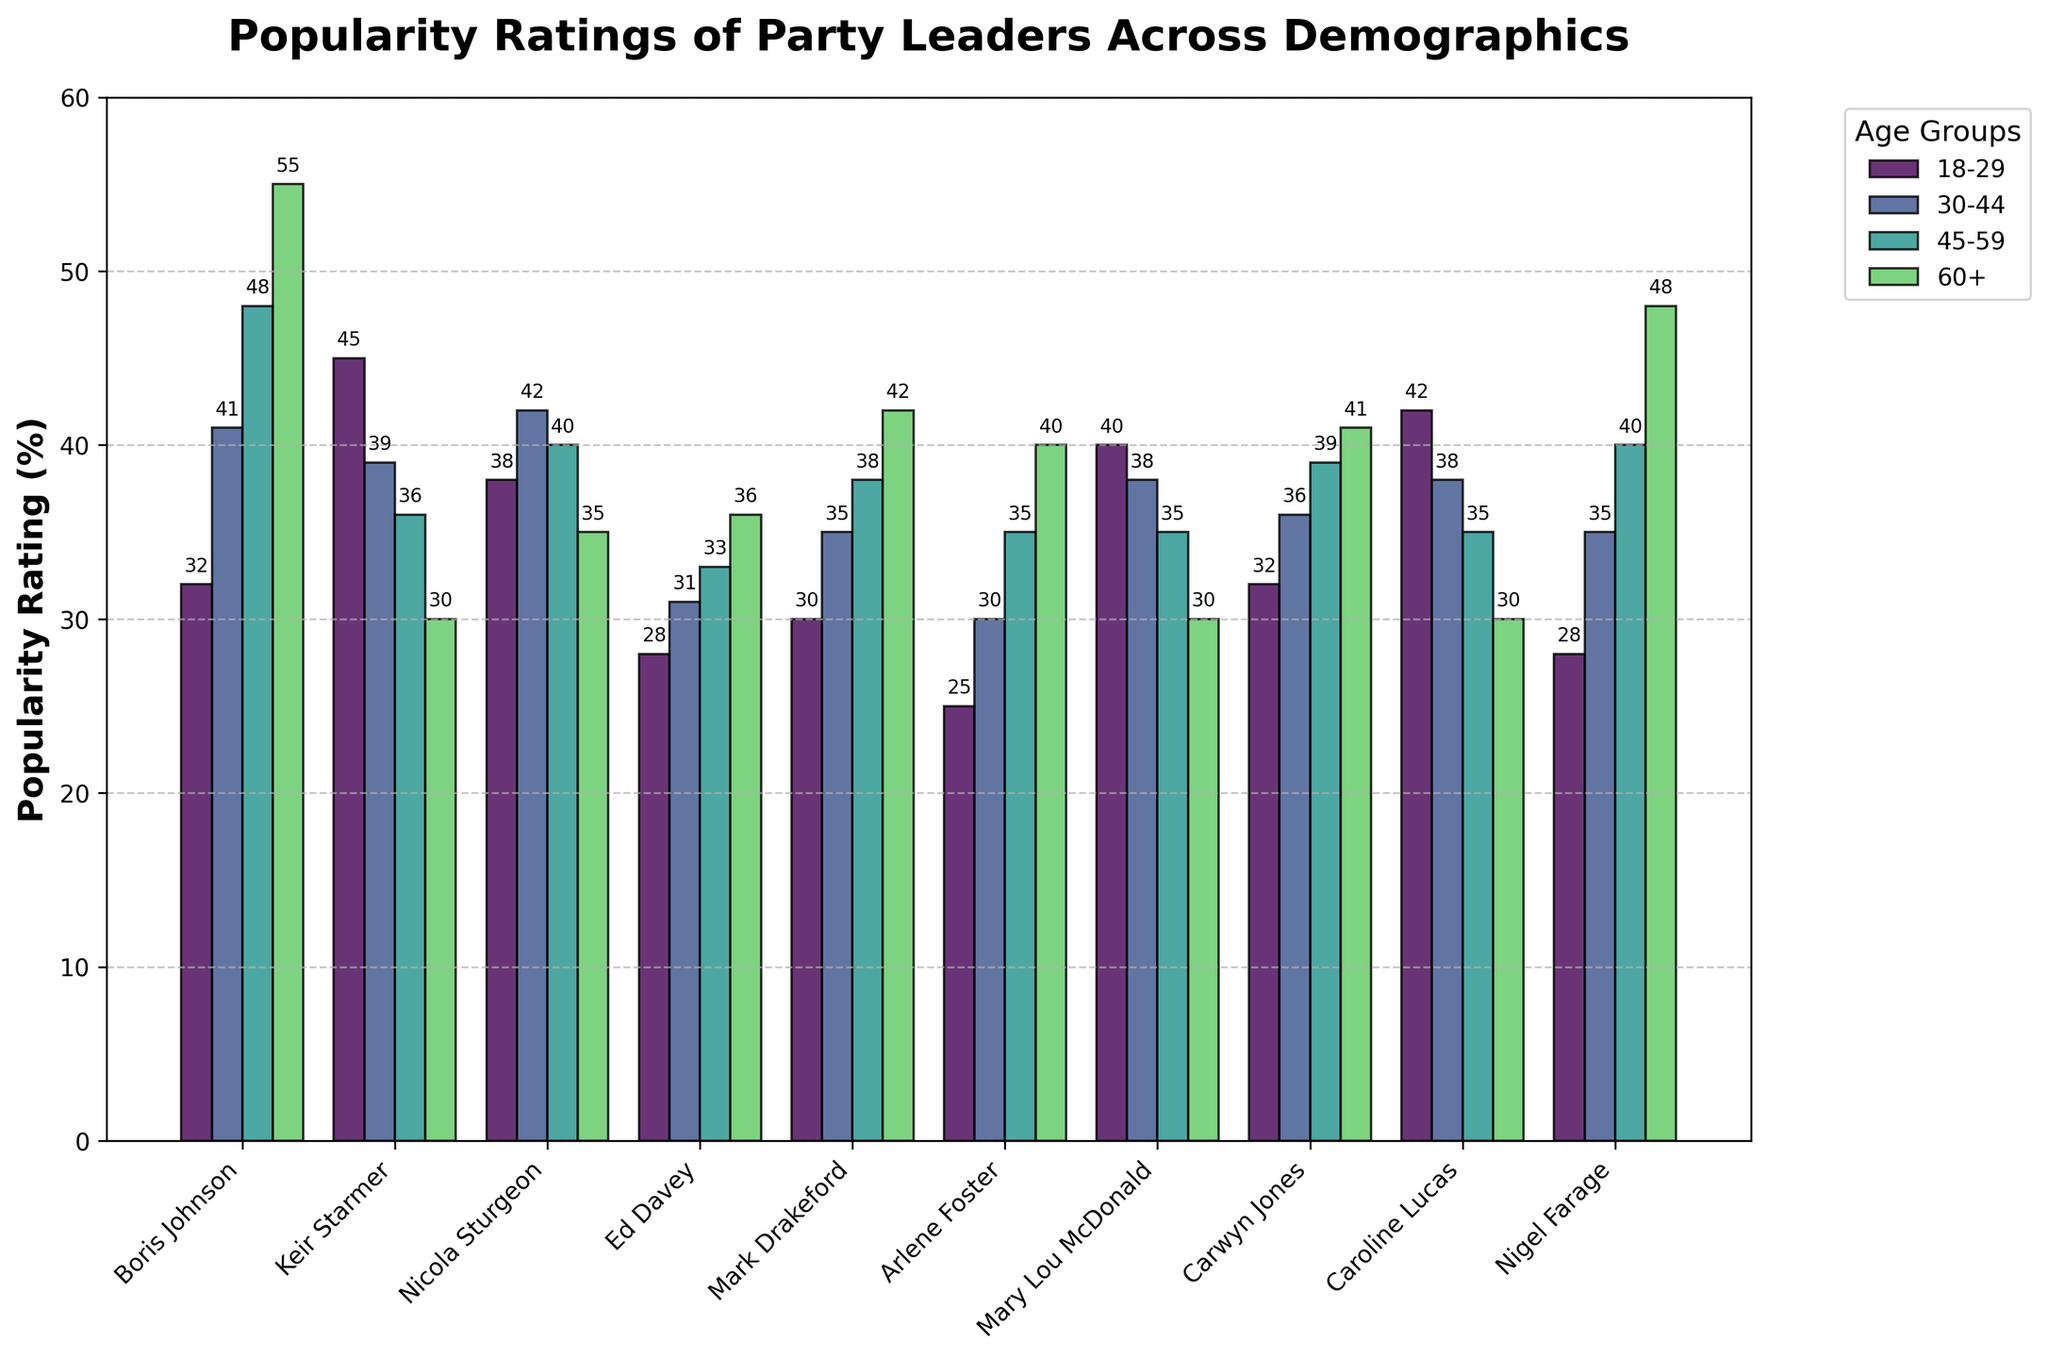What is the popularity rating of Boris Johnson among those aged 60+? Look for the bar corresponding to Boris Johnson and the age group 60+. The top of this bar indicates his popularity rating for this group, which is 55%.
Answer: 55 Who has the highest popularity rating among those aged 18-29? Identify the bars corresponding to the 18-29 age group for all leaders. Caroline Lucas has the highest bar with a rating of 42%.
Answer: Caroline Lucas Compare the popularity ratings of Keir Starmer and Mary Lou McDonald among the 45-59 age group. Who is more popular? Look for the bars corresponding to Keir Starmer and Mary Lou McDonald in the 45-59 age group. Keir Starmer's rating is 36%, while Mary Lou McDonald's rating is 35%. Keir Starmer is more popular.
Answer: Keir Starmer Which leader shows the largest increase in popularity rating from the 18-29 to the 60+ age group and by how much? Calculate the difference in popularity ratings for all leaders between the 18-29 and the 60+ age groups. Boris Johnson shows the largest increase from 32% to 55%, which is an increment of 23%.
Answer: Boris Johnson, 23% Sum the popularity ratings of Caroline Lucas across all age groups. Add the popularity ratings of Caroline Lucas: 42% (18-29) + 38% (30-44) + 35% (45-59) + 30% (60+). Calculate the total sum: 42 + 38 + 35 + 30 = 145%.
Answer: 145 Who has the lowest popularity rating among those aged 30-44? Identify the bars corresponding to the 30-44 age group for all leaders. Arlene Foster has the lowest bar with a rating of 30%.
Answer: Arlene Foster What is the average popularity rating of Ed Davey across all age groups? Calculate the average of Ed Davey's popularity ratings: (28% + 31% + 33% + 36%) / 4. Sum up the values first: 28 + 31 + 33 + 36 = 128. Then, divide by 4: 128 / 4 = 32%.
Answer: 32 Identify the leader whose popularity rating decreases consistently across each older age group. For each leader, check if the rating decreases from one age group to the next older one. Mary Lou McDonald has ratings that decrease consistently: 40% (18-29), 38% (30-44), 35% (45-59), 30% (60+).
Answer: Mary Lou McDonald What is the average popularity rating of Mark Drakeford and Carwyn Jones among those aged 60+? Calculate the average of Mark Drakeford and Carwyn Jones' popularity ratings for the 60+ age group: (42% + 41%) / 2. Sum up the values first: 42 + 41 = 83. Then, divide by 2: 83 / 2 = 41.5%.
Answer: 41.5 